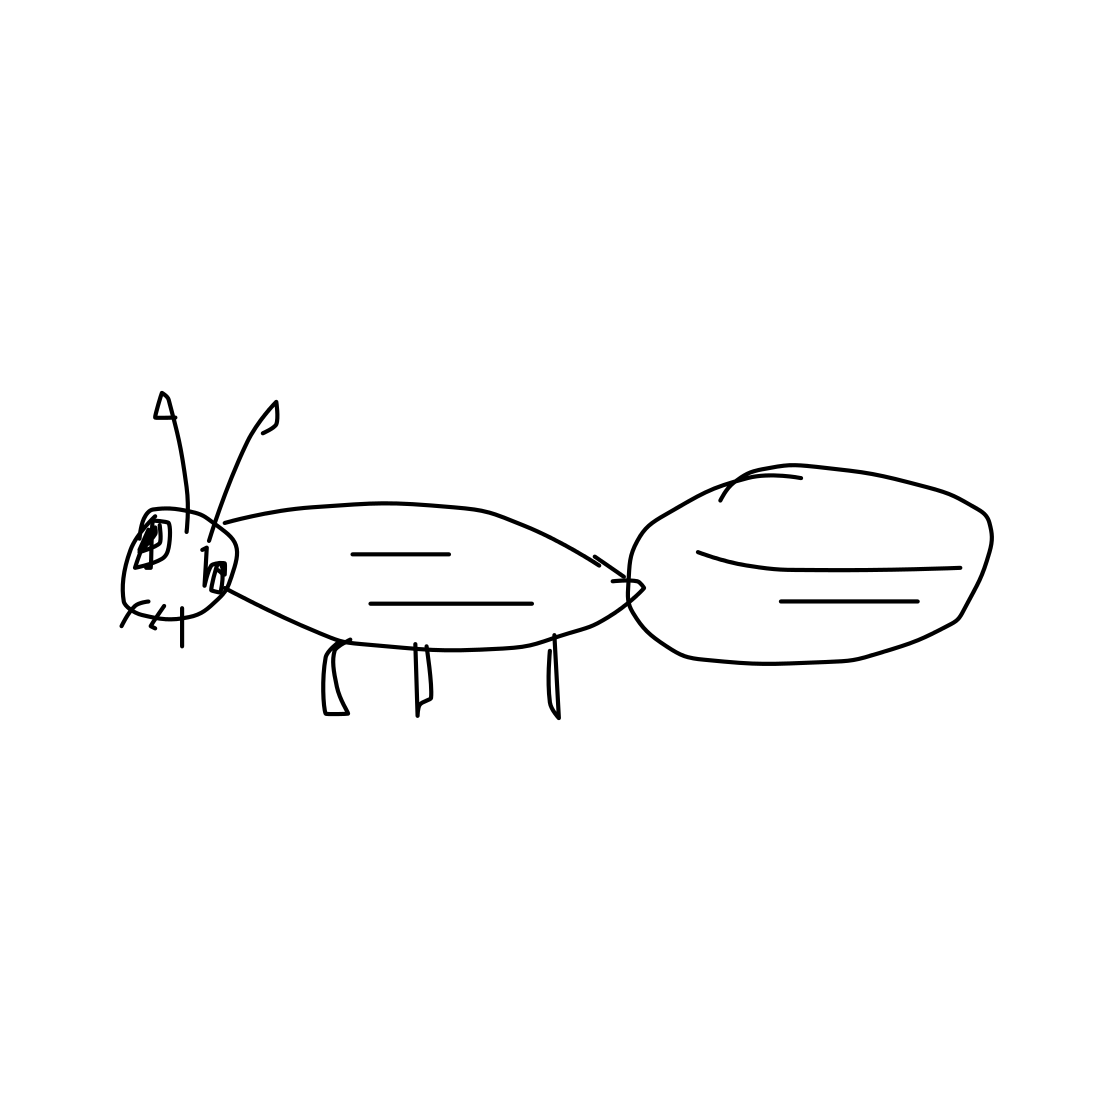How does this sketch help in understanding the basic structure of an ant? This sketch simplifies the ant's anatomy into clear, distinguishable parts such as the head, thorax, and abdomen, which are crucial for understanding how ants are segmented. The depiction of legs and antennae, although minimalistic, serves as a basic introduction to important physical features used for movement and sensory functions. It's an effective educational tool for highlighting key biological aspects in a visually accessible manner. 